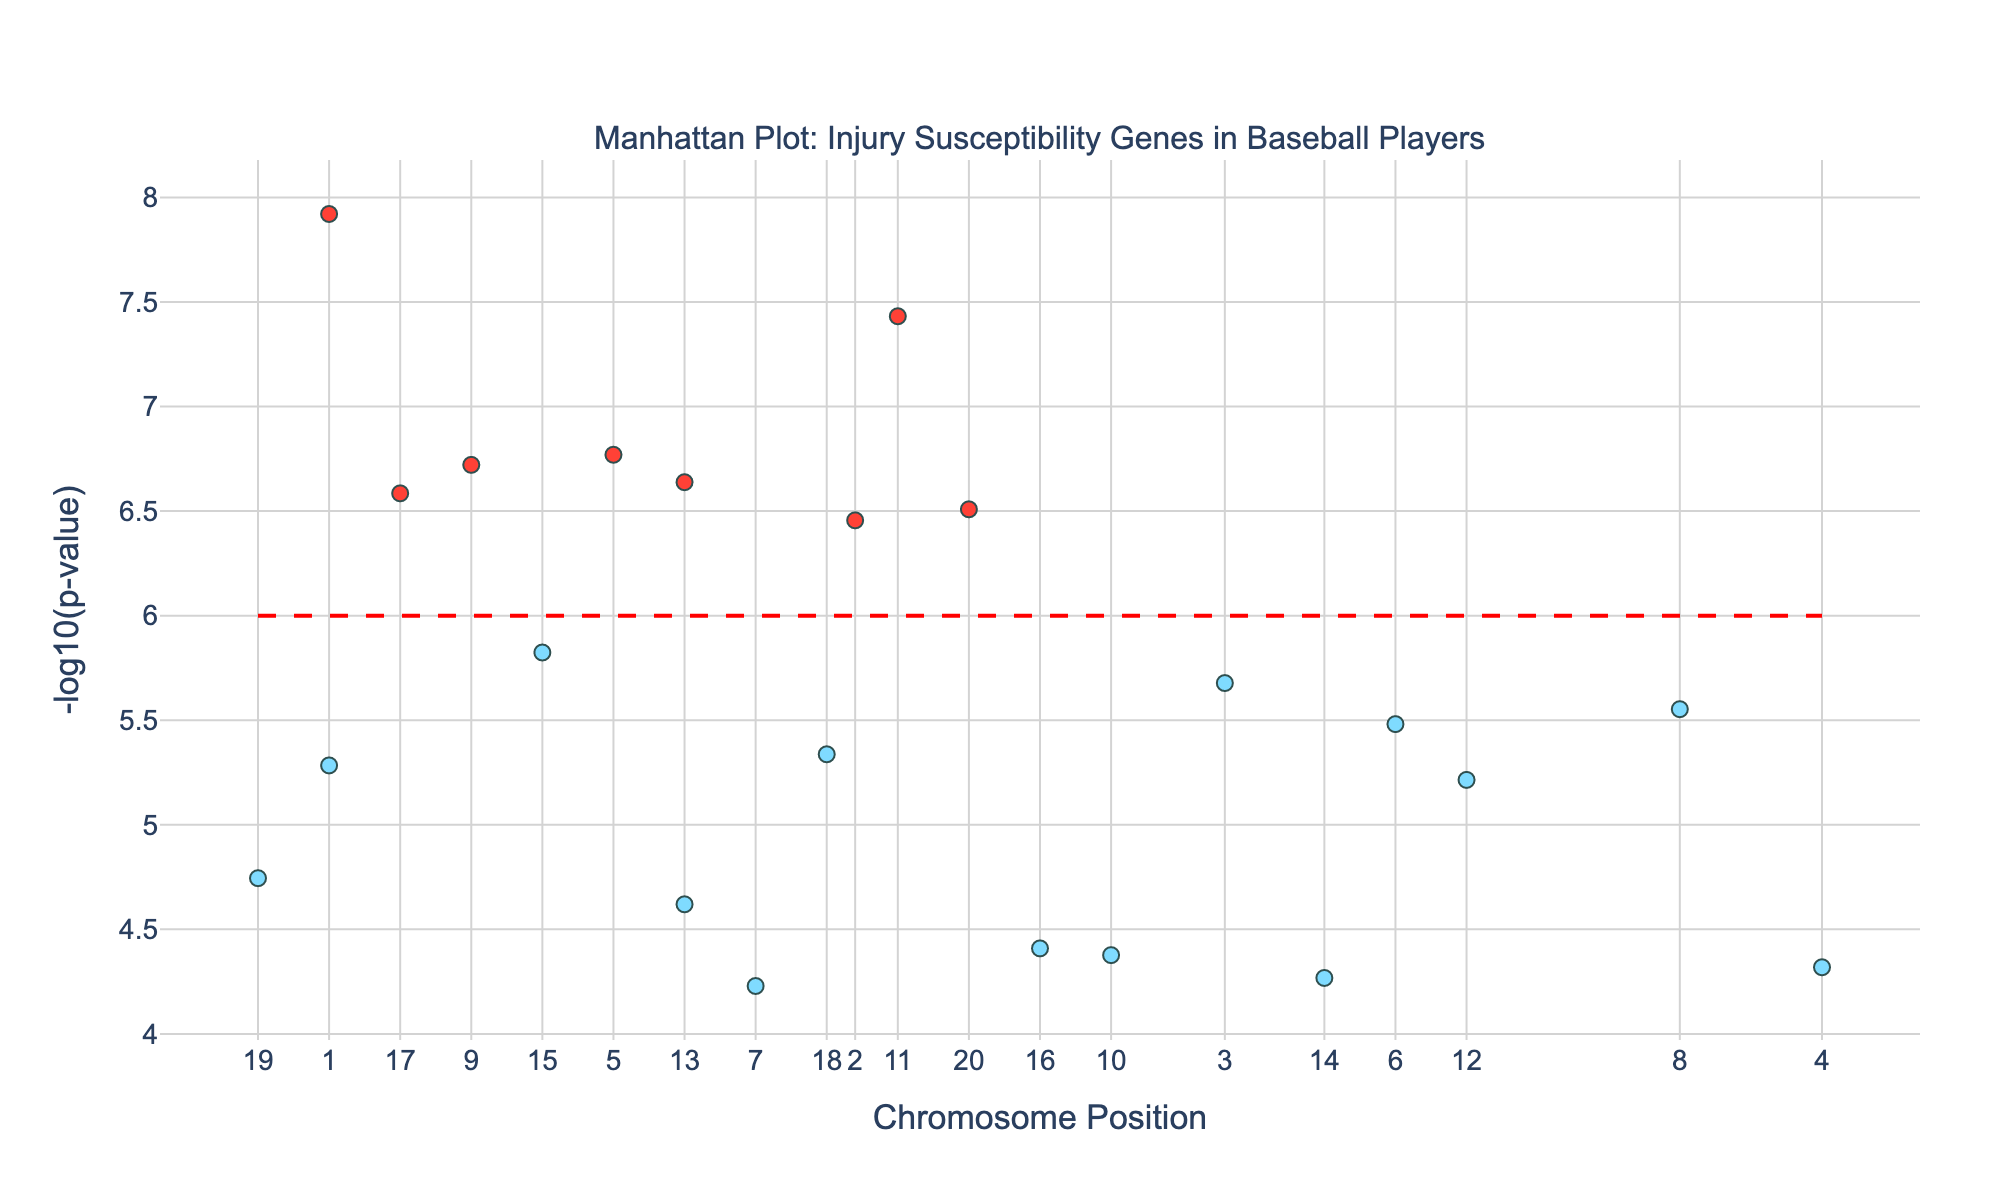What is the highest point on the y-axis? Identify the maximum value of the y-axis by observing the highest point in the plot.
Answer: Around 8.9 Which gene has the lowest p-value? Find the point that is the highest on the y-axis and check its corresponding gene label in the hover information.
Answer: IL6 How many genes have p-values significant enough to be colored red in the plot? Count the number of points that are colored red, as these indicate significant p-values below the threshold of 1e-6.
Answer: 6 Compare the gene positions between chromosome 1 and chromosome 11. Which chromosome has a gene located at a higher position? Check the positions on the x-axis for chromosomes 1 and 11.
Answer: Chromosome 11 Which gene is located at the highest position within chromosome 5? Locate chromosome 5 on the x-axis, then identify the gene corresponding to the highest point within that chromosome range.
Answer: IGF1 What is the gene with the second smallest p-value? After identifying the gene with the smallest p-value, find the next highest point on the y-axis and check its corresponding gene label.
Answer: MSTN Are there any genes on chromosome 20, and if yes, which one? Check the x-axis for chromosome 20 and see if there are any points plotted along this position, then identify the gene.
Answer: GDF5 What is the purpose of the dashed red line on the plot? The dashed red line shows the significance threshold for p-values, which is typically 1e-6.
Answer: Significance threshold Which chromosome has the highest number of significant genes? Count the number of red points within each chromosome range on the x-axis.
Answer: Chromosome 1 (1 gene) What is the gene on chromosome 9, and what is its p-value? Identify the position for chromosome 9 on the x-axis and check the corresponding gene label and y-axis value.
Answer: VEGFA, 1.9e-7 